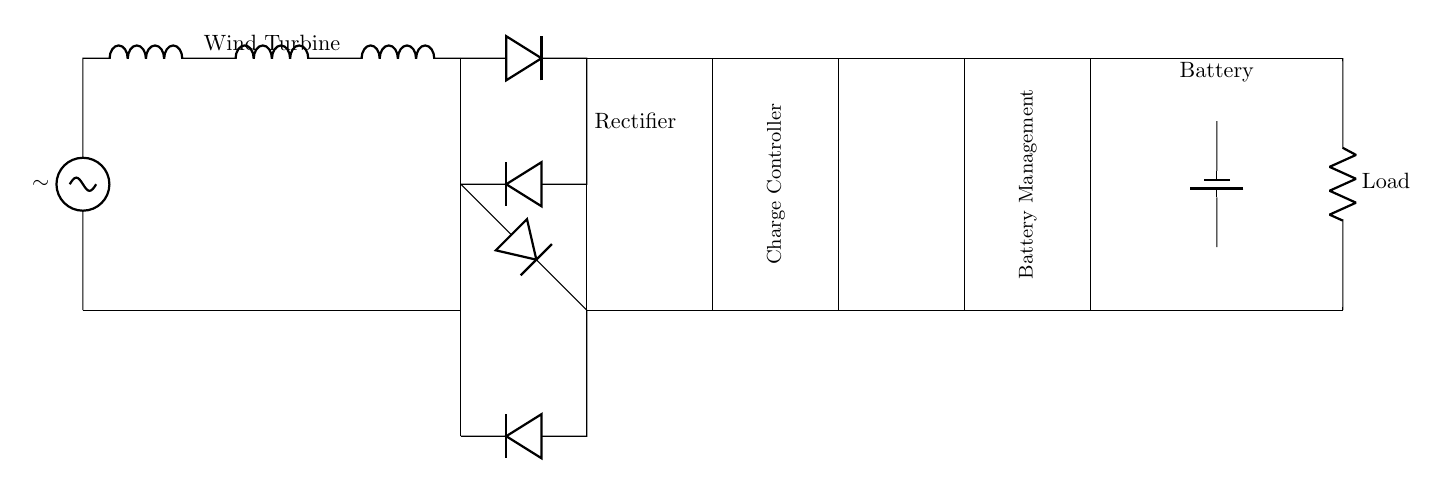What is the main power source in this circuit? The main power source is the wind turbine, indicated at the start of the circuit diagram. It generates alternating current, symbolized by the tilde.
Answer: wind turbine What is the function of the rectifier in this circuit? The rectifier converts the alternating current generated by the wind turbine into direct current for further processing and use. This is indicated by the arrangement of diodes.
Answer: convert AC to DC How many batteries are shown in the diagram? Only one battery is depicted in the circuit, represented as a single battery symbol located towards the end of the diagram.
Answer: one What component follows the rectifier in the circuit? The component following the rectifier is the charge controller, which manages the charging of the battery from the rectified output. It is shown as a rectangle next to the rectifier.
Answer: charge controller What type of load is connected at the end of the circuit? A resistive load is connected at the end of the circuit, identified by the resistor symbol with the label "Load."
Answer: resistive load Why is a battery management system included in the circuit? The battery management system is included to monitor and manage the battery's charging and discharging processes, ensuring optimal operation and longevity, as indicated by its label in the diagram.
Answer: monitor and manage battery What type of circuit is this? This is a renewable energy circuit designed for portable wind turbine power generation, integrating components like a rectifier, charge controller, battery management, and load together as a power system.
Answer: renewable energy circuit 